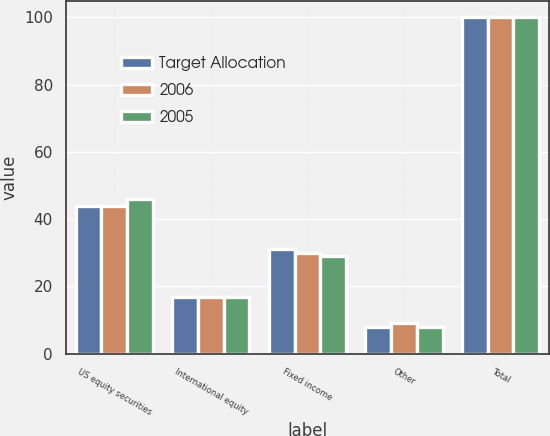<chart> <loc_0><loc_0><loc_500><loc_500><stacked_bar_chart><ecel><fcel>US equity securities<fcel>International equity<fcel>Fixed income<fcel>Other<fcel>Total<nl><fcel>Target Allocation<fcel>44<fcel>17<fcel>31<fcel>8<fcel>100<nl><fcel>2006<fcel>44<fcel>17<fcel>30<fcel>9<fcel>100<nl><fcel>2005<fcel>46<fcel>17<fcel>29<fcel>8<fcel>100<nl></chart> 